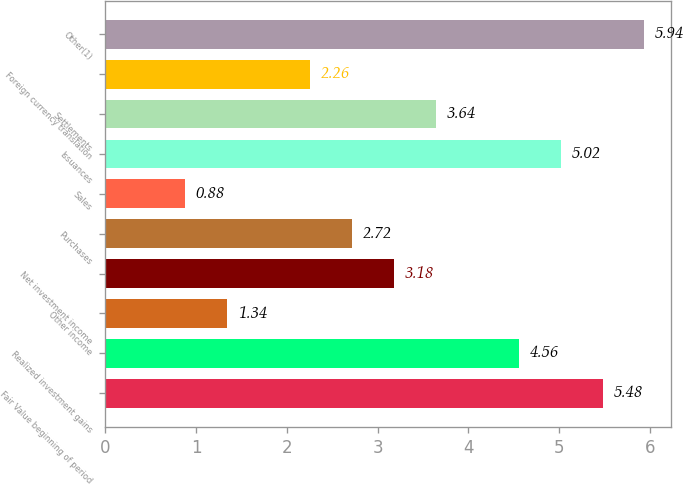Convert chart. <chart><loc_0><loc_0><loc_500><loc_500><bar_chart><fcel>Fair Value beginning of period<fcel>Realized investment gains<fcel>Other income<fcel>Net investment income<fcel>Purchases<fcel>Sales<fcel>Issuances<fcel>Settlements<fcel>Foreign currency translation<fcel>Other(1)<nl><fcel>5.48<fcel>4.56<fcel>1.34<fcel>3.18<fcel>2.72<fcel>0.88<fcel>5.02<fcel>3.64<fcel>2.26<fcel>5.94<nl></chart> 